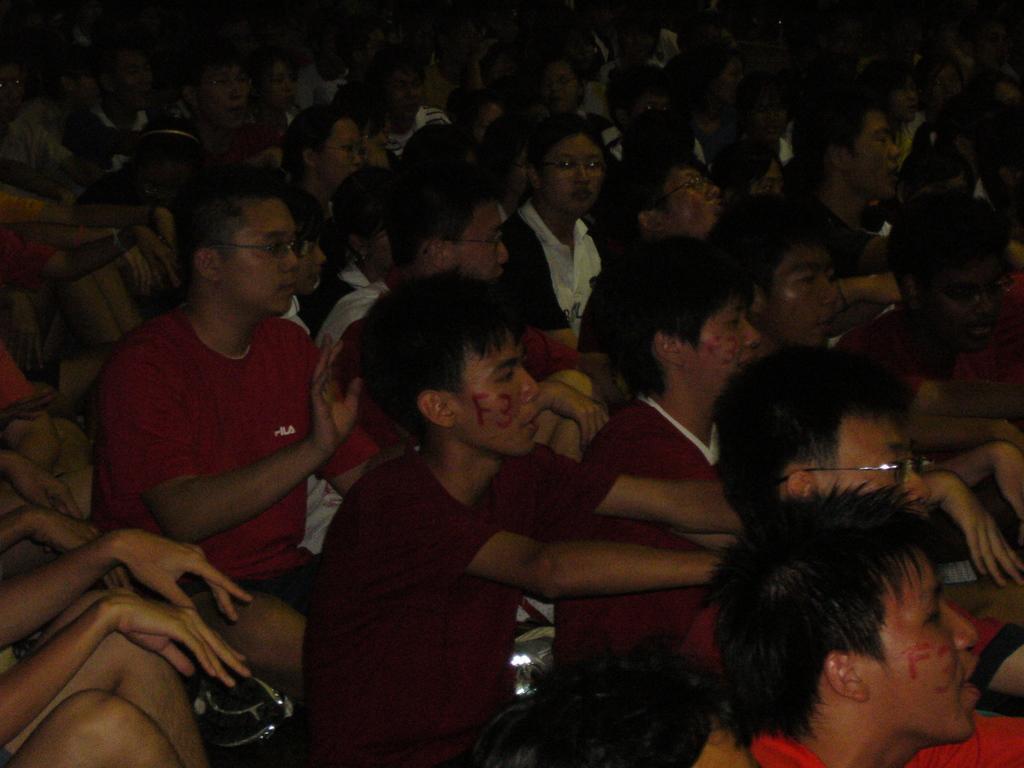Describe this image in one or two sentences. In this image I can see number of people are sitting. I can see most of them are wearing specs. I can also see this image is little bit in dark from background and here I can see something is written. 